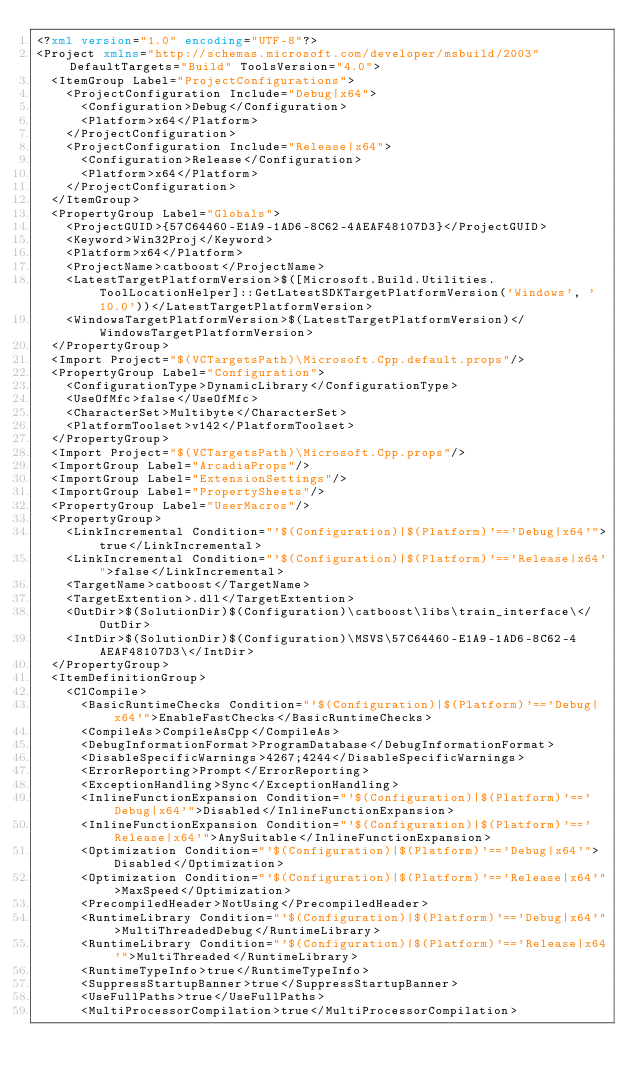<code> <loc_0><loc_0><loc_500><loc_500><_XML_><?xml version="1.0" encoding="UTF-8"?>
<Project xmlns="http://schemas.microsoft.com/developer/msbuild/2003" DefaultTargets="Build" ToolsVersion="4.0">
  <ItemGroup Label="ProjectConfigurations">
    <ProjectConfiguration Include="Debug|x64">
      <Configuration>Debug</Configuration>
      <Platform>x64</Platform>
    </ProjectConfiguration>
    <ProjectConfiguration Include="Release|x64">
      <Configuration>Release</Configuration>
      <Platform>x64</Platform>
    </ProjectConfiguration>
  </ItemGroup>
  <PropertyGroup Label="Globals">
    <ProjectGUID>{57C64460-E1A9-1AD6-8C62-4AEAF48107D3}</ProjectGUID>
    <Keyword>Win32Proj</Keyword>
    <Platform>x64</Platform>
    <ProjectName>catboost</ProjectName>
    <LatestTargetPlatformVersion>$([Microsoft.Build.Utilities.ToolLocationHelper]::GetLatestSDKTargetPlatformVersion('Windows', '10.0'))</LatestTargetPlatformVersion>
    <WindowsTargetPlatformVersion>$(LatestTargetPlatformVersion)</WindowsTargetPlatformVersion>
  </PropertyGroup>
  <Import Project="$(VCTargetsPath)\Microsoft.Cpp.default.props"/>
  <PropertyGroup Label="Configuration">
    <ConfigurationType>DynamicLibrary</ConfigurationType>
    <UseOfMfc>false</UseOfMfc>
    <CharacterSet>Multibyte</CharacterSet>
    <PlatformToolset>v142</PlatformToolset>
  </PropertyGroup>
  <Import Project="$(VCTargetsPath)\Microsoft.Cpp.props"/>
  <ImportGroup Label="ArcadiaProps"/>
  <ImportGroup Label="ExtensionSettings"/>
  <ImportGroup Label="PropertySheets"/>
  <PropertyGroup Label="UserMacros"/>
  <PropertyGroup>
    <LinkIncremental Condition="'$(Configuration)|$(Platform)'=='Debug|x64'">true</LinkIncremental>
    <LinkIncremental Condition="'$(Configuration)|$(Platform)'=='Release|x64'">false</LinkIncremental>
    <TargetName>catboost</TargetName>
    <TargetExtention>.dll</TargetExtention>
    <OutDir>$(SolutionDir)$(Configuration)\catboost\libs\train_interface\</OutDir>
    <IntDir>$(SolutionDir)$(Configuration)\MSVS\57C64460-E1A9-1AD6-8C62-4AEAF48107D3\</IntDir>
  </PropertyGroup>
  <ItemDefinitionGroup>
    <ClCompile>
      <BasicRuntimeChecks Condition="'$(Configuration)|$(Platform)'=='Debug|x64'">EnableFastChecks</BasicRuntimeChecks>
      <CompileAs>CompileAsCpp</CompileAs>
      <DebugInformationFormat>ProgramDatabase</DebugInformationFormat>
      <DisableSpecificWarnings>4267;4244</DisableSpecificWarnings>
      <ErrorReporting>Prompt</ErrorReporting>
      <ExceptionHandling>Sync</ExceptionHandling>
      <InlineFunctionExpansion Condition="'$(Configuration)|$(Platform)'=='Debug|x64'">Disabled</InlineFunctionExpansion>
      <InlineFunctionExpansion Condition="'$(Configuration)|$(Platform)'=='Release|x64'">AnySuitable</InlineFunctionExpansion>
      <Optimization Condition="'$(Configuration)|$(Platform)'=='Debug|x64'">Disabled</Optimization>
      <Optimization Condition="'$(Configuration)|$(Platform)'=='Release|x64'">MaxSpeed</Optimization>
      <PrecompiledHeader>NotUsing</PrecompiledHeader>
      <RuntimeLibrary Condition="'$(Configuration)|$(Platform)'=='Debug|x64'">MultiThreadedDebug</RuntimeLibrary>
      <RuntimeLibrary Condition="'$(Configuration)|$(Platform)'=='Release|x64'">MultiThreaded</RuntimeLibrary>
      <RuntimeTypeInfo>true</RuntimeTypeInfo>
      <SuppressStartupBanner>true</SuppressStartupBanner>
      <UseFullPaths>true</UseFullPaths>
      <MultiProcessorCompilation>true</MultiProcessorCompilation></code> 